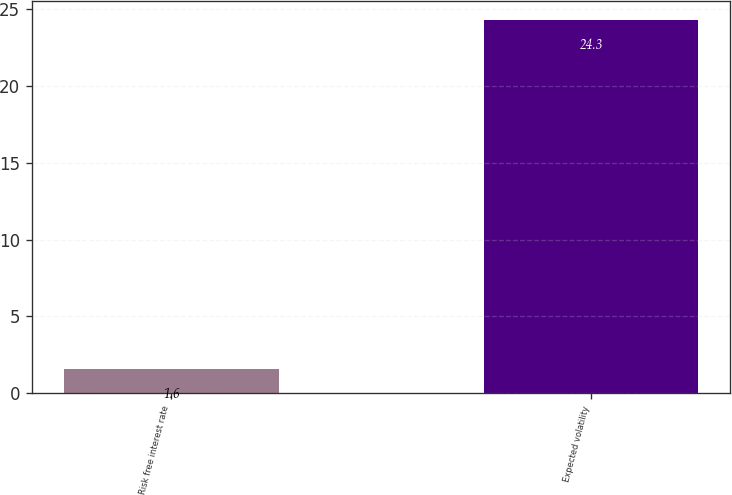Convert chart. <chart><loc_0><loc_0><loc_500><loc_500><bar_chart><fcel>Risk free interest rate<fcel>Expected volatility<nl><fcel>1.6<fcel>24.3<nl></chart> 